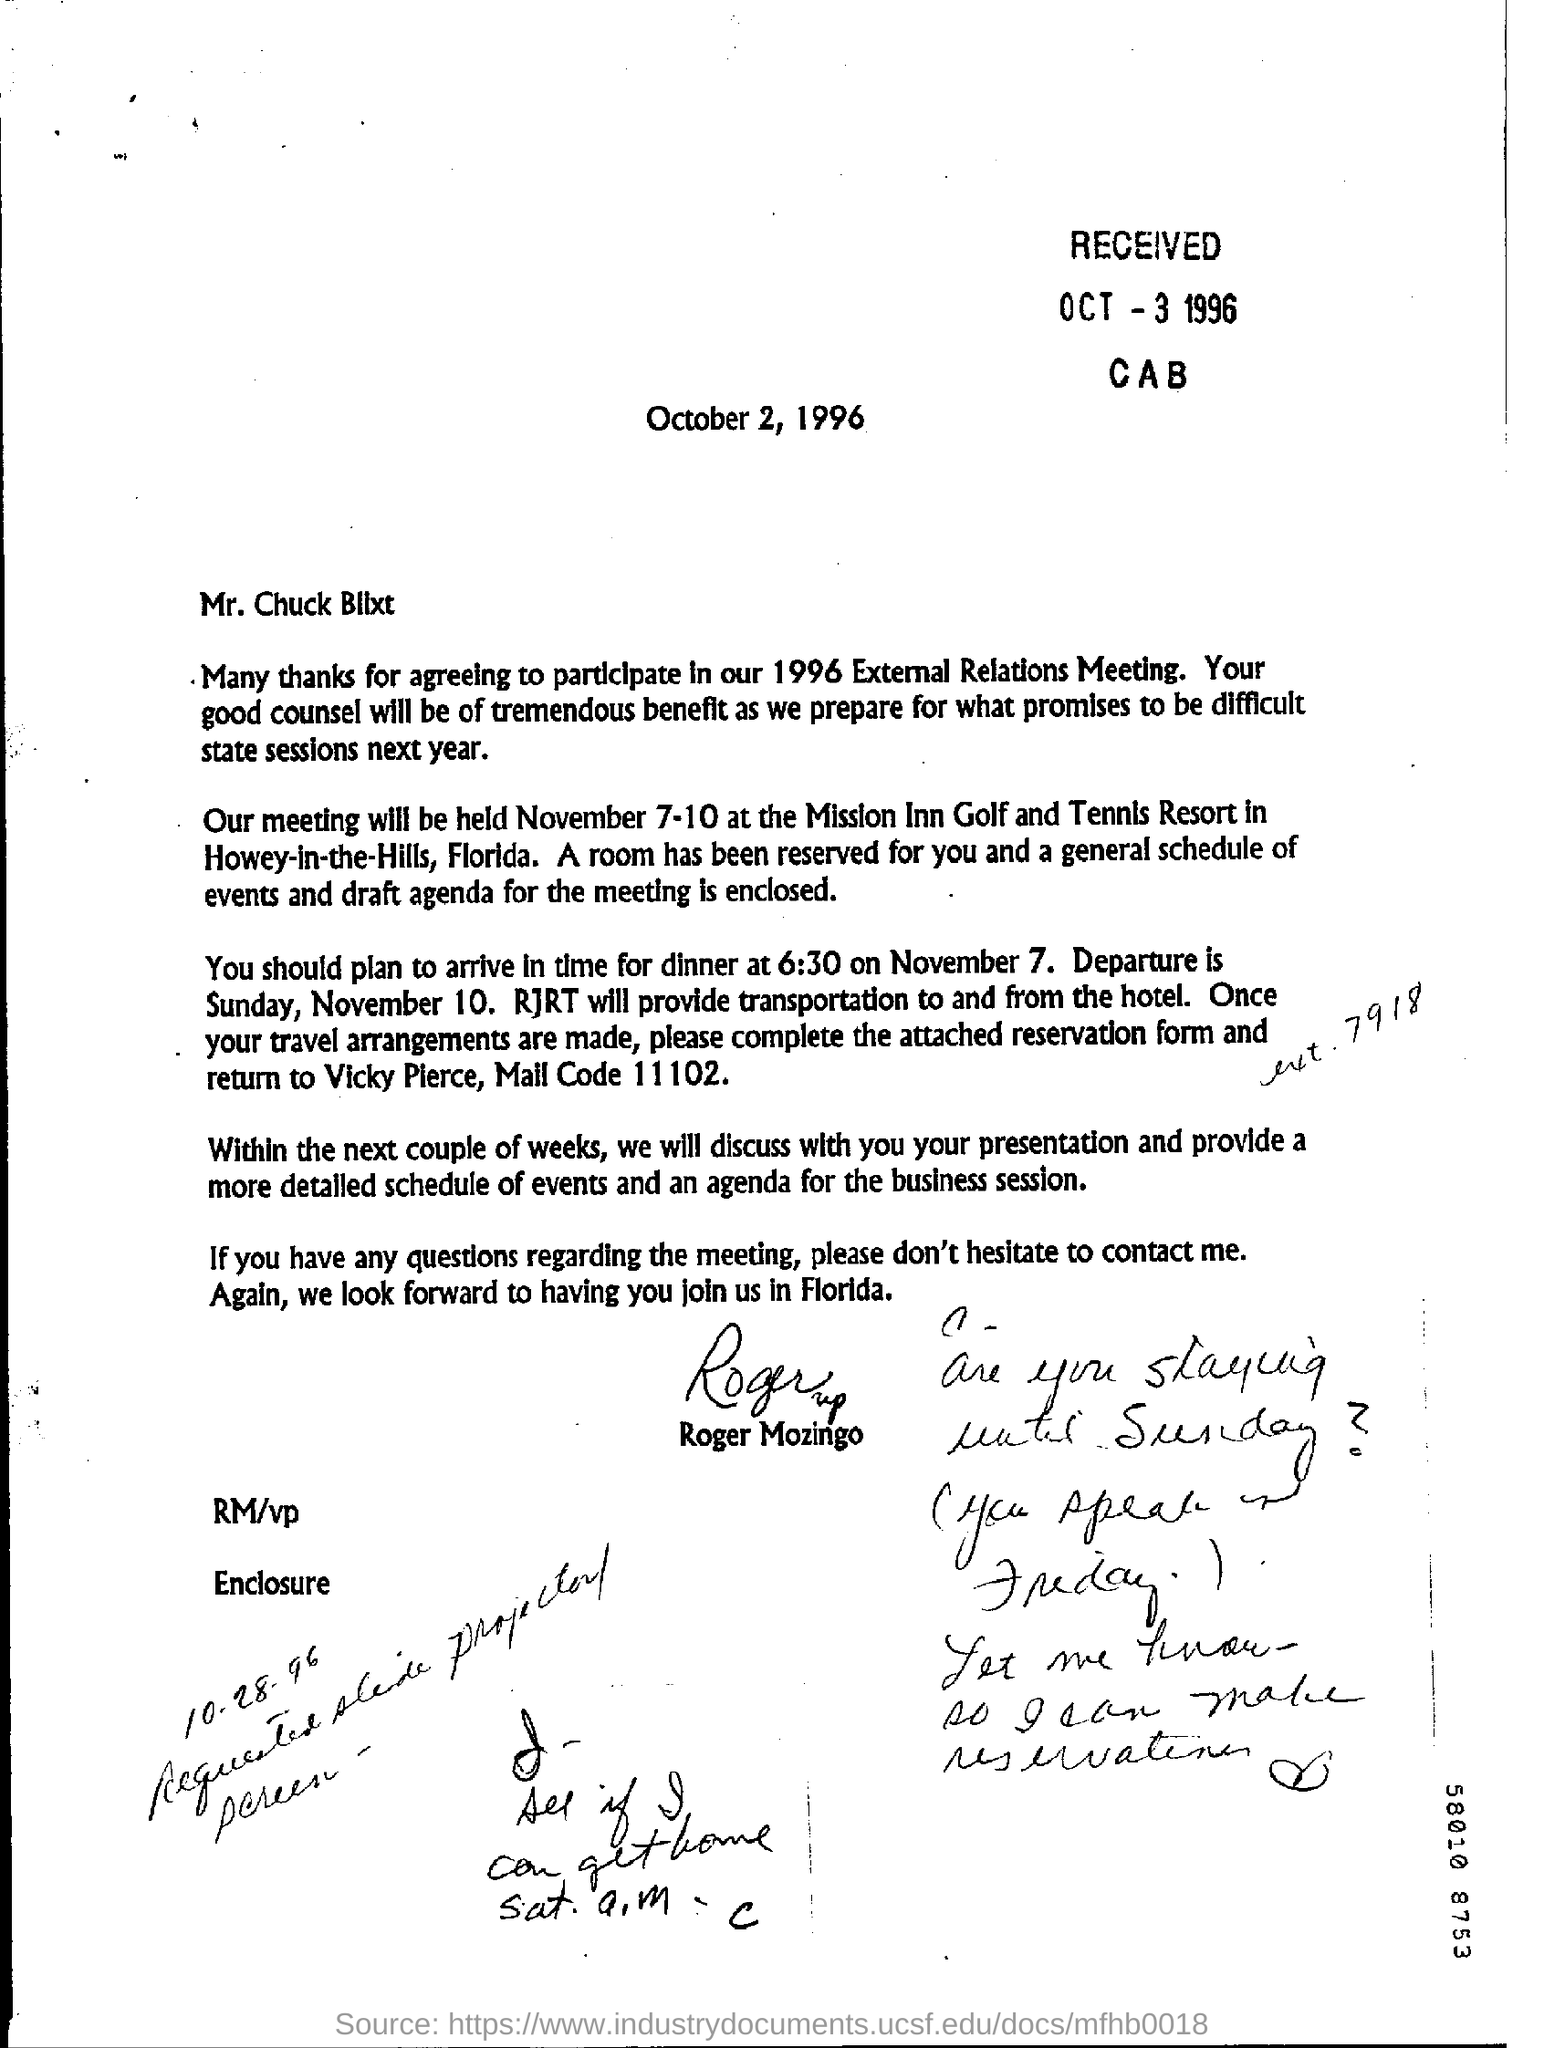What is the recieved date?
Ensure brevity in your answer.  Oct 3 1996. To whom its written?
Give a very brief answer. Mr.chuck bllxt. When the meeting is going to be held?
Your answer should be very brief. November 7-10. Place where meeting is going to held
Your answer should be very brief. Howey-in-the-Hills, Florida. What is the date of departure?
Your answer should be very brief. November 10. What is year mentioned?
Offer a terse response. 1996. 